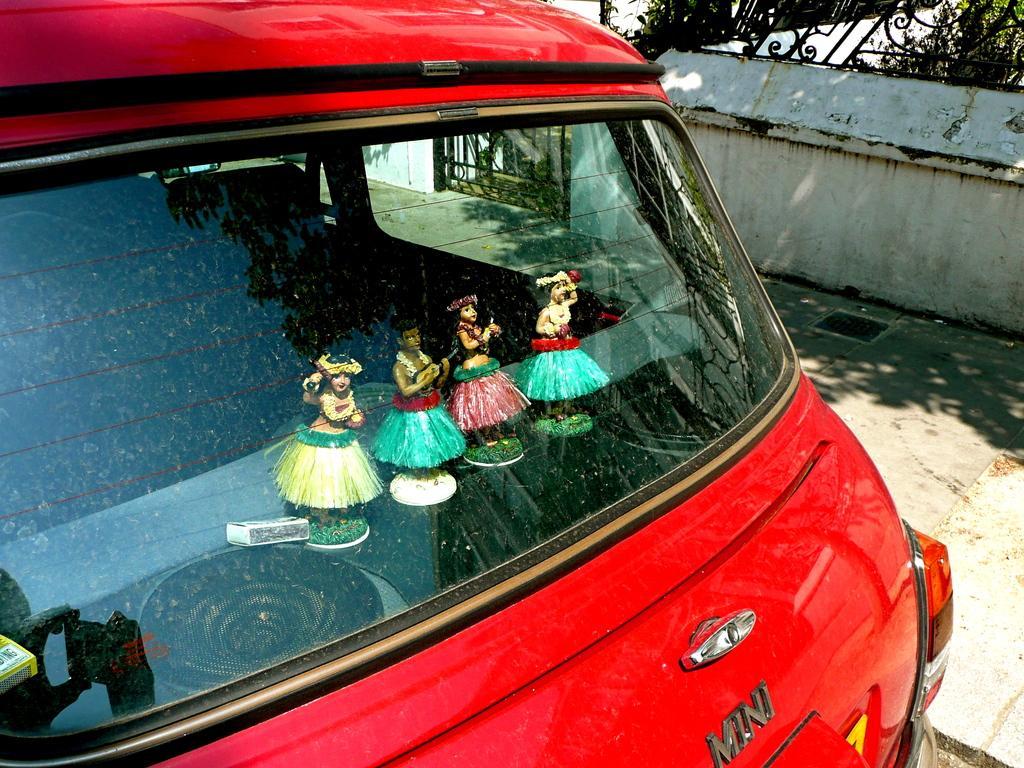Could you give a brief overview of what you see in this image? In the image we can see there are decorated cartoon toys of women standing on the piece of grass kept inside near the dicky of the car. The car is parked on the ground and behind there is an iron gate and there are iron railings on the wall. 